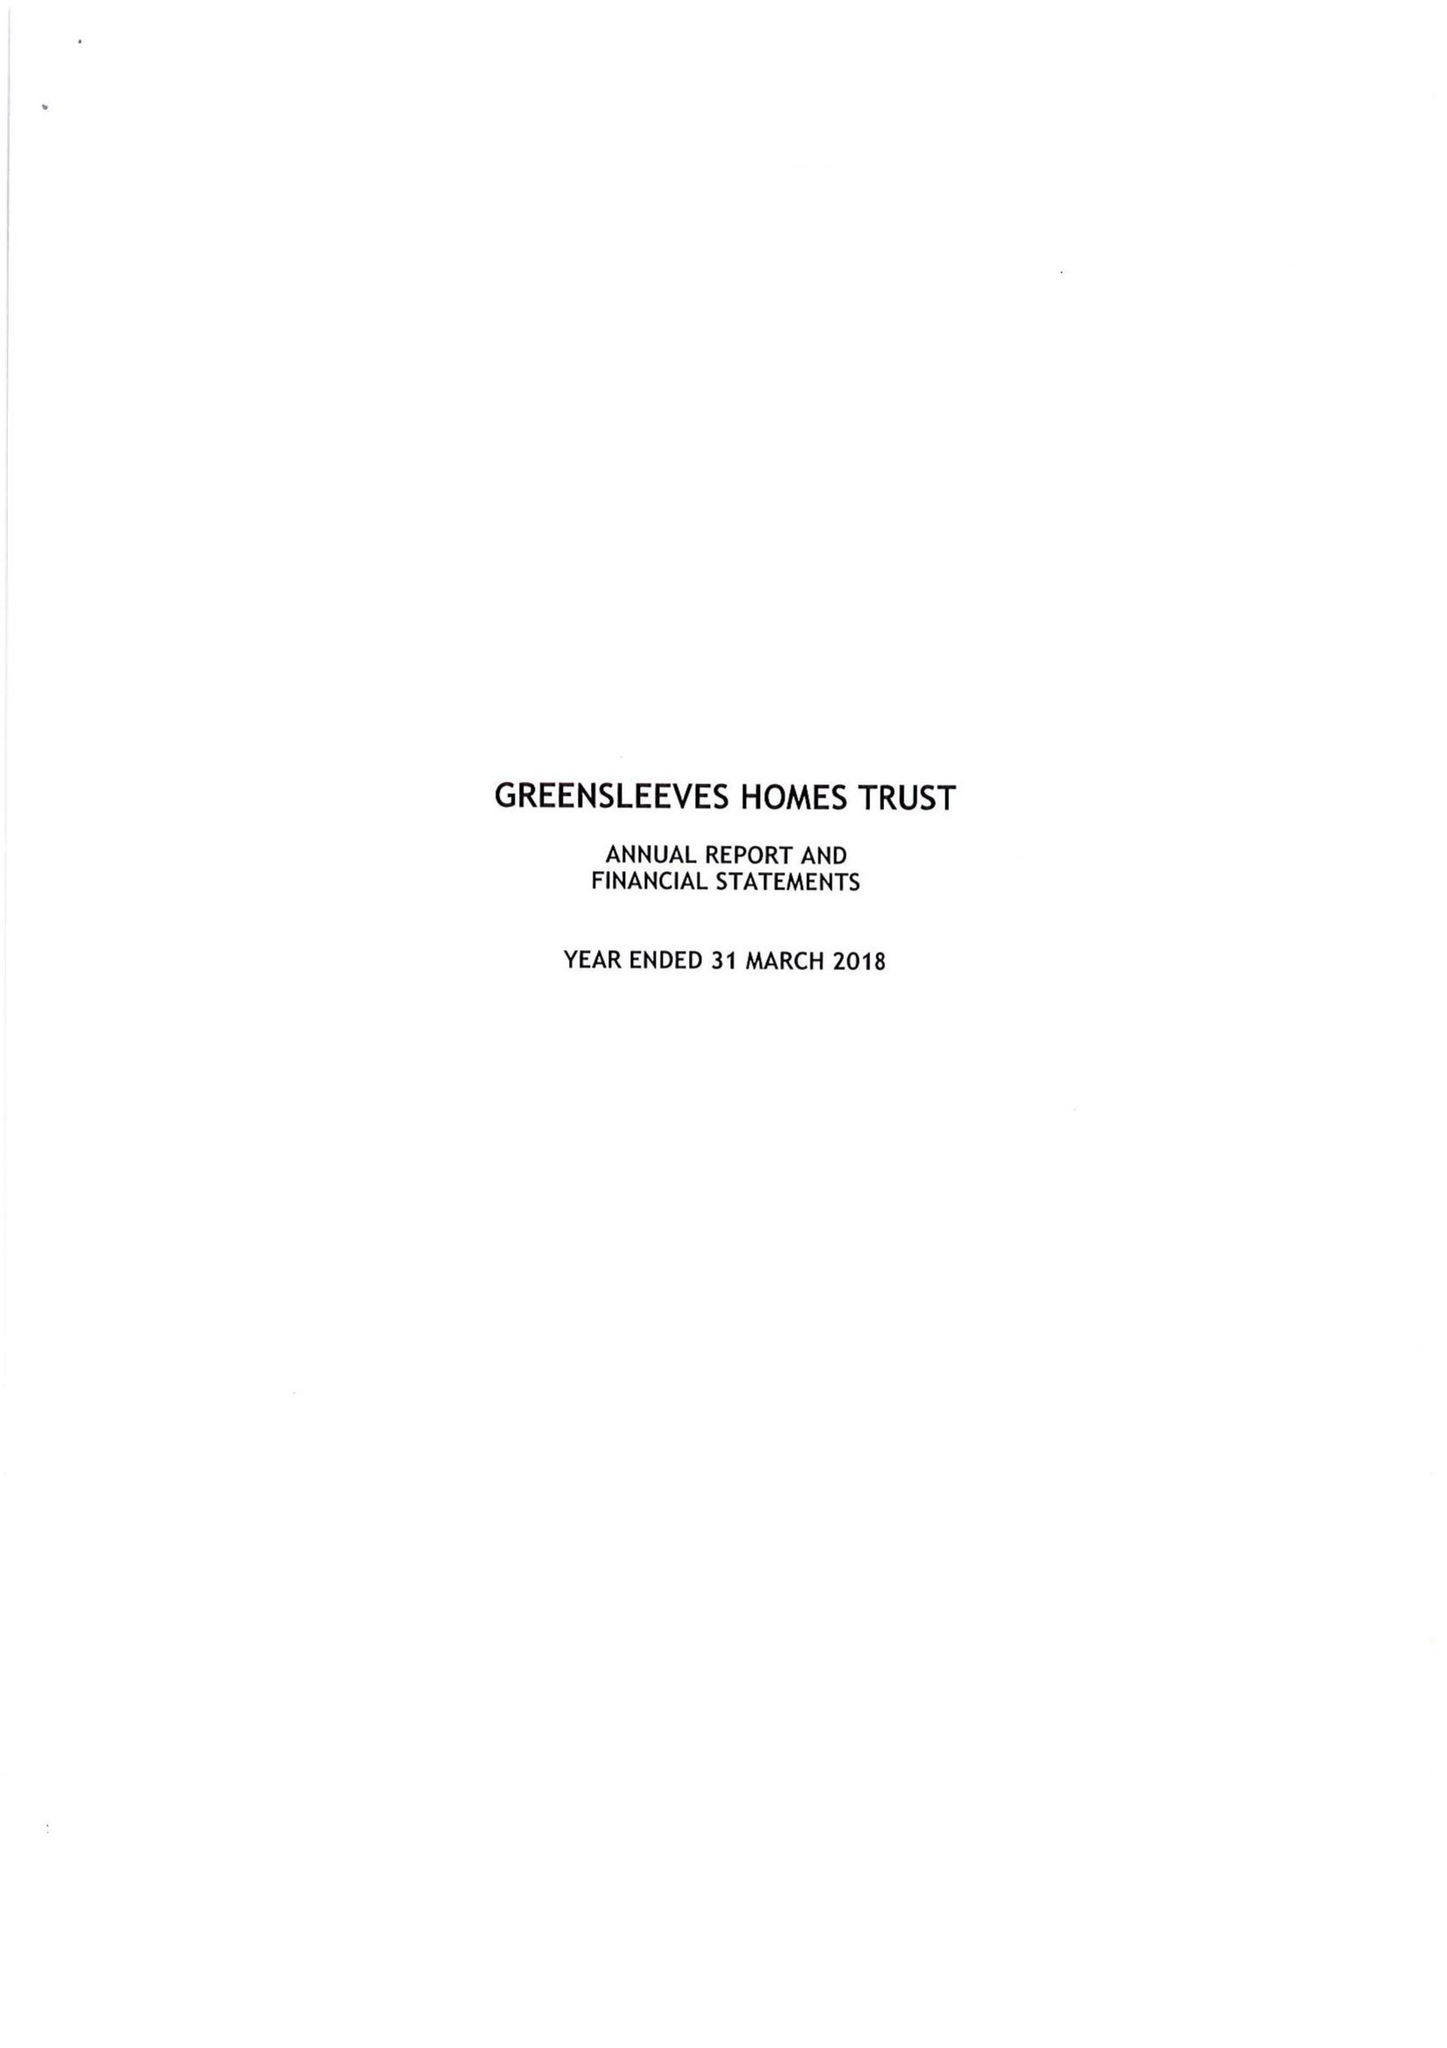What is the value for the spending_annually_in_british_pounds?
Answer the question using a single word or phrase. 33878415.00 